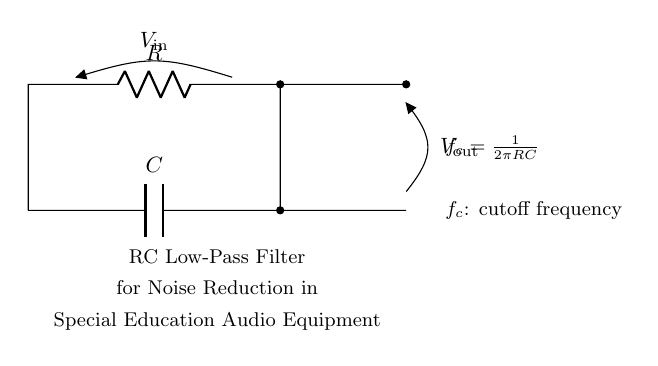What is the input voltage in this circuit? The input voltage is represented as V_in in the circuit diagram. It is indicated at the top left, connected to the resistor.
Answer: V_in Which components are present in the circuit? The components visible in the circuit are a resistor and a capacitor, as labeled R and C, respectively.
Answer: Resistor and Capacitor What is the purpose of the circuit? The circuit is identified as an RC low-pass filter, intended for noise reduction in audio equipment for special education purposes.
Answer: Noise reduction What does f_c represent in the circuit? In the context of the circuit, f_c is the cutoff frequency formula, which indicates the frequency limit where signals above this point are attenuated.
Answer: Cutoff frequency How do you calculate the cutoff frequency of this RC filter? The formula for calculating the cutoff frequency f_c is given as f_c = 1/(2πRC). This is derived from the relationship between resistance, capacitance, and frequency in the filter design.
Answer: One over two pi RC What is the primary function of the capacitor in this circuit? The capacitor in this circuit primarily serves to store electrical energy and block DC signals while allowing AC signals to pass through, which reduces noise.
Answer: Store energy and block DC What happens to high-frequency signals in this circuit? In an RC low-pass filter, high-frequency signals are significantly attenuated, meaning they are reduced and weakened as they pass through the circuit due to the impedance of the capacitor.
Answer: They are attenuated 